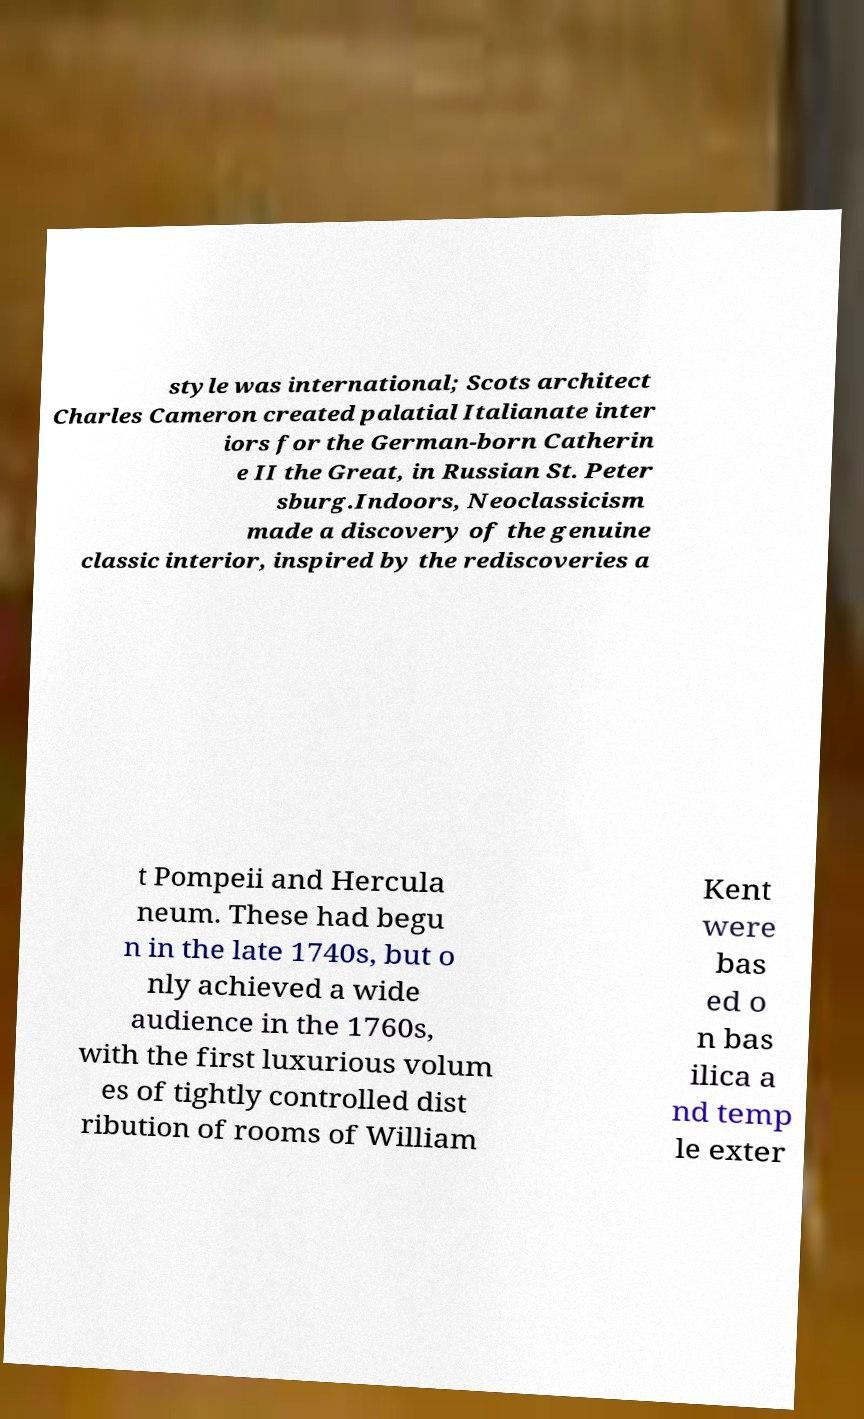What messages or text are displayed in this image? I need them in a readable, typed format. style was international; Scots architect Charles Cameron created palatial Italianate inter iors for the German-born Catherin e II the Great, in Russian St. Peter sburg.Indoors, Neoclassicism made a discovery of the genuine classic interior, inspired by the rediscoveries a t Pompeii and Hercula neum. These had begu n in the late 1740s, but o nly achieved a wide audience in the 1760s, with the first luxurious volum es of tightly controlled dist ribution of rooms of William Kent were bas ed o n bas ilica a nd temp le exter 